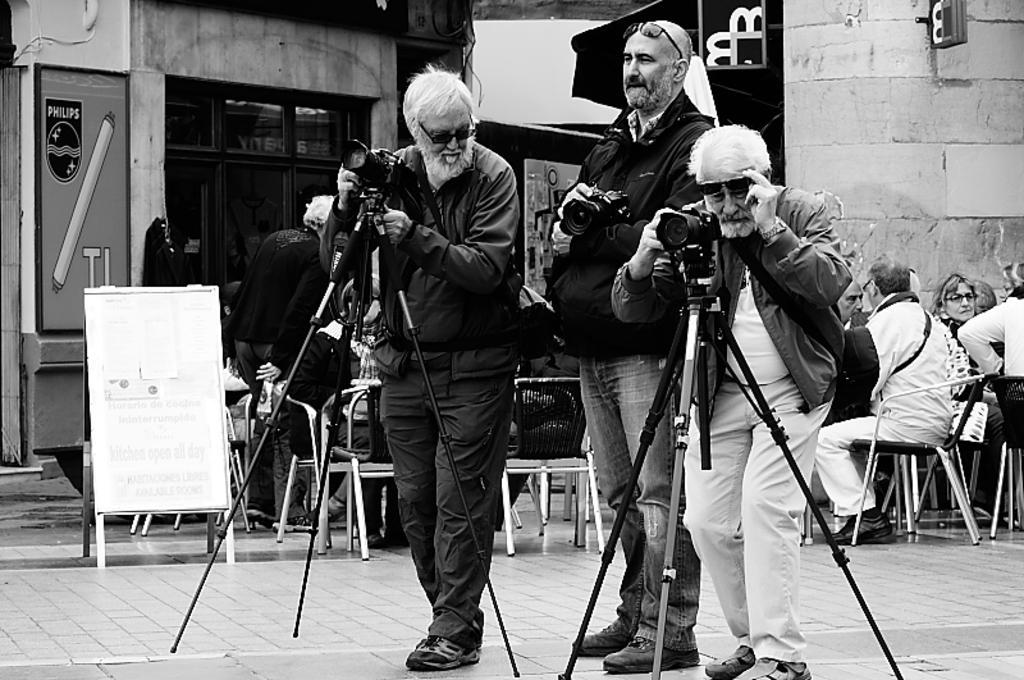Please provide a concise description of this image. In this image I can see three persons standing and holding camera. Background I can see few people sitting, a stall, a board attached to the wall and the image is in black and white. 